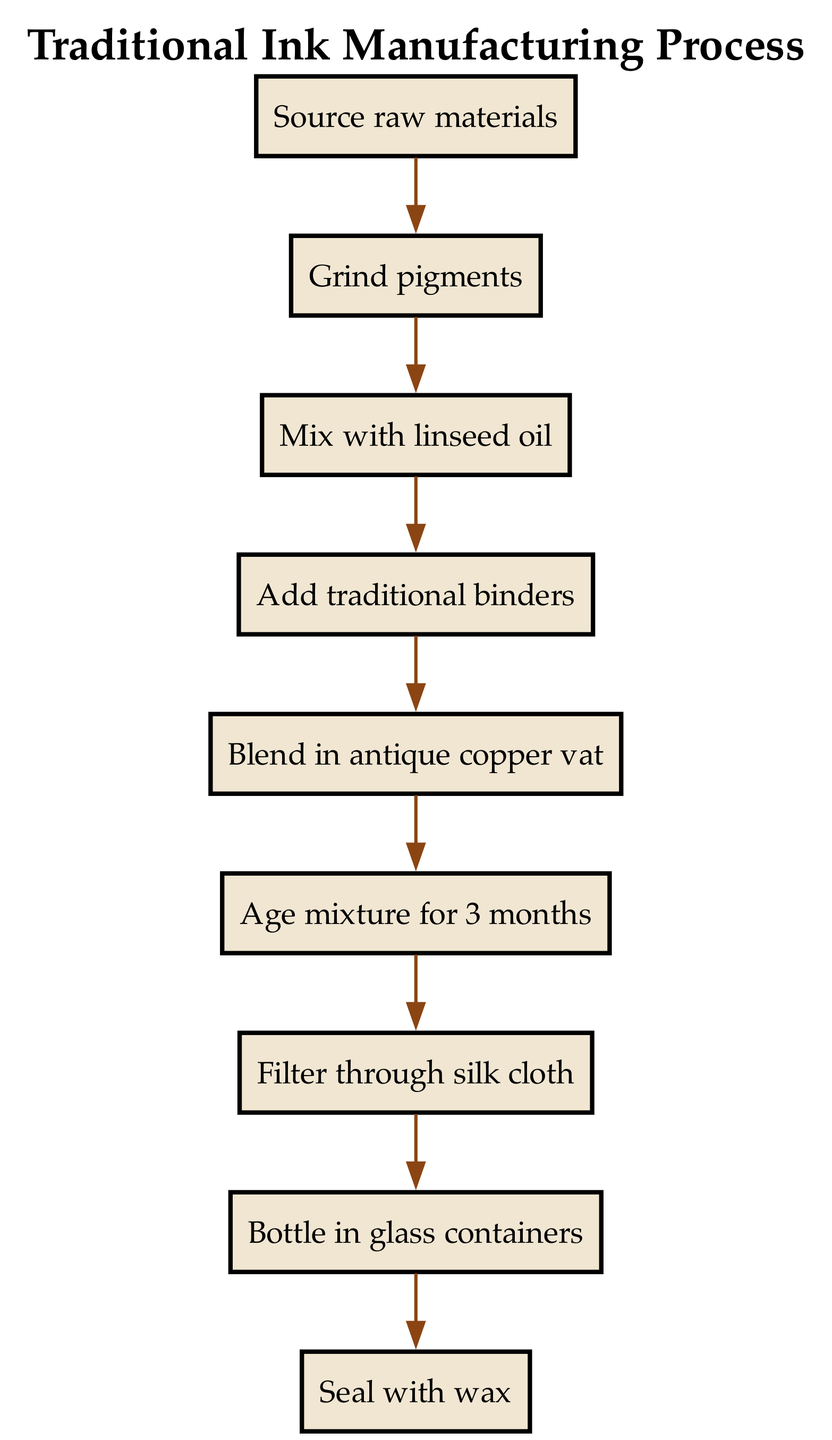What is the first step in the traditional ink manufacturing process? The first step is to "Source raw materials," which is the initial action taken before any processing begins.
Answer: Source raw materials How many steps are in the traditional ink manufacturing process? Counting each unique step in the flow chart, there are a total of nine steps from sourcing raw materials to sealing with wax.
Answer: Nine What is mixed with pigments at the third step? At the third step, the pigments are mixed with "linseed oil" to create a homogeneous mixture essential for the ink.
Answer: Linseed oil What is the final step in the traditional ink manufacturing process? The last action depicted in the flow chart is to "Seal with wax," which ensures the ink is properly enclosed for storage or sale.
Answer: Seal with wax Which step follows the aging process? After the "Age mixture for 3 months" step (step 6), the next action is to "Filter through silk cloth" (step 7), indicating the further refinement of the ink product.
Answer: Filter through silk cloth What happens after the mixture is filtered? Once the mixture is filtered through silk cloth (step 7), it is then "Bottle in glass containers" (step 8), indicating the packaging stage in the process.
Answer: Bottle in glass containers Which step involves using an antique copper vat? The fifth step is where the mixture is "Blend in antique copper vat," highlighting a traditional aspect of the manufacturing process.
Answer: Blend in antique copper vat What is the purpose of the silk cloth in the process? The silk cloth is used during the "Filter through silk cloth" step, which is crucial for ensuring that any particulate matter is removed from the ink mixture before bottling.
Answer: Filter through silk cloth How long is the mixture aged? The aging process requires a duration of "3 months," which allows the ingredients to mature and develop the desired properties of the ink.
Answer: 3 months 